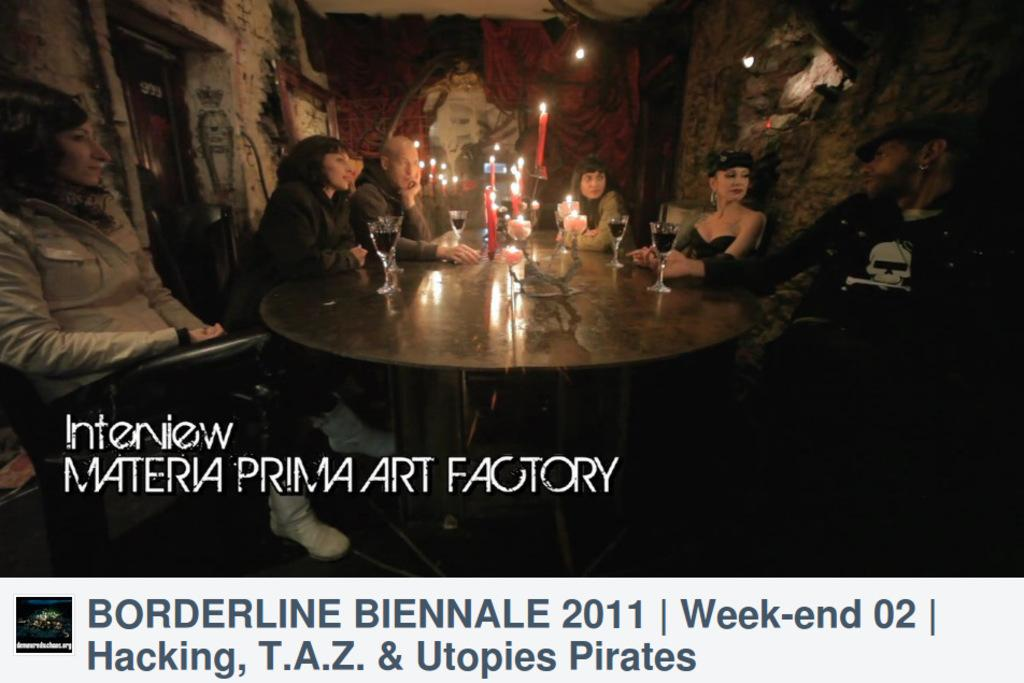What are the people in the image doing? The persons in the image are sitting on chairs. What is present on the table in the image? There are glasses and candles on the table. What is the background of the image? There is a wall in the background of the image. What type of cushion is used to control the brush in the image? There is no cushion or brush present in the image. 